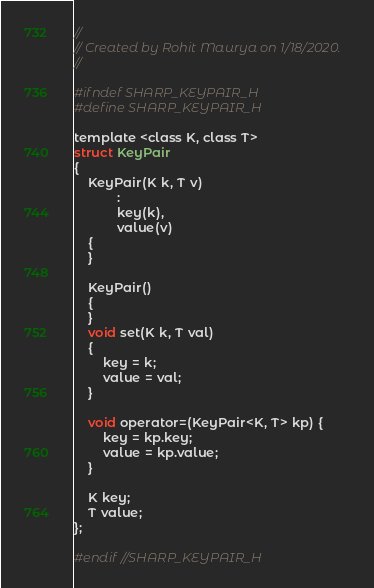<code> <loc_0><loc_0><loc_500><loc_500><_C_>//
// Created by Rohit Maurya on 1/18/2020.
//

#ifndef SHARP_KEYPAIR_H
#define SHARP_KEYPAIR_H

template <class K, class T>
struct KeyPair
{
    KeyPair(K k, T v)
            :
            key(k),
            value(v)
    {
    }

    KeyPair()
    {
    }
    void set(K k, T val)
    {
        key = k;
        value = val;
    }

    void operator=(KeyPair<K, T> kp) {
        key = kp.key;
        value = kp.value;
    }

    K key;
    T value;
};

#endif //SHARP_KEYPAIR_H
</code> 